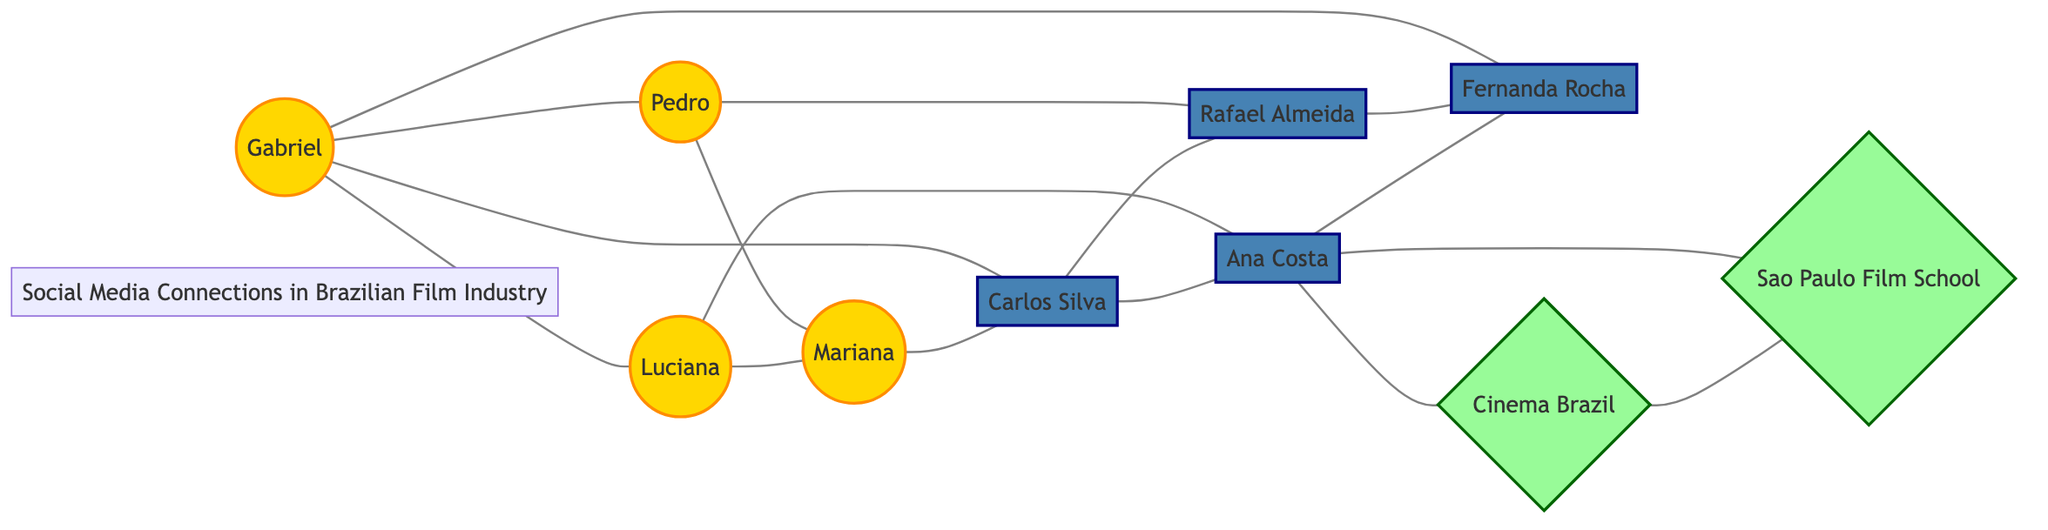What is the total number of nodes in the graph? To find the total number of nodes, we count each unique individual and institution listed in the data. There are 10 nodes: Gabriel, Luciana, Pedro, Mariana, Carlos Silva, Ana Costa, Rafael Almeida, Fernanda Rocha, Cinema Brazil, and Sao Paulo Film School.
Answer: 10 How many aspiring actors are connected to Carlos Silva? We can look at the links in the diagram where Carlos Silva is the source or target. He is connected to Gabriel, Mariana, and Ana Costa, making a total of 3 aspiring actors connected to him.
Answer: 3 Name one institution connected to Ana Costa. By examining the links, we see that Ana Costa is connected to two institutions: Fernanda Rocha and Cinema Brazil. Thus, one valid answer is Cinema Brazil or Fernanda Rocha.
Answer: Cinema Brazil Which aspiring actor is connected to the most professionals? Looking closely at the connections, we see that Gabriel has links to Carlos Silva and Fernanda Rocha, while Luciana has a link to Ana Costa. Therefore, Gabriel has the most connections (2) with professionals.
Answer: Gabriel List the names of all actors connected to Mariana. Analyzing the edges, Mariana is linked to Pedro, Luciana, and Carlos Silva. So, the actors connected to Mariana are Pedro and Luciana.
Answer: Pedro, Luciana How many edges connect aspiring actors to one another? We count the connections among the aspiring actors only. The links are Gabriel to Luciana, Gabriel to Pedro, Luciana to Mariana, and Pedro to Mariana. This gives us a total of 4 edges connecting the aspiring actors.
Answer: 4 Which professional is connected to the most aspiring actors? Reviewing the diagram, we determine which professionals have the most connections to aspiring actors. Carlos Silva is connected to Gabriel and Mariana (2 aspiring actors). Thus, the answer is Carlos Silva.
Answer: Carlos Silva What kind of connection is between Cinema Brazil and Sao Paulo Film School? By looking at the data, the connection between Cinema Brazil and Sao Paulo Film School is an institutional link, indicating a relationship between organizations within the film industry.
Answer: institutional 